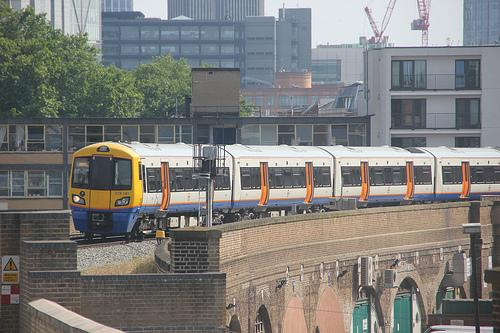In a single sentence, summarize the key components of the image and their locations. The image features a modern train on elevated tracks, surrounded by urban buildings and distant construction cranes. Briefly mention the central theme of the image and the dominant colors seen. The central theme of the image is urban transportation, with dominant colors including blue, white, and grey. Point out any interesting details about the train in the image. The train has a sleek, modern design with a predominantly blue and white color scheme. Describe the scene where the image takes place in terms of the elements captured. The scene takes place in an urban setting with a train on elevated tracks, surrounded by various buildings and distant construction cranes. Describe the overall atmosphere of the image, considering its elements and colors. The image conveys a bustling urban atmosphere, characterized by a modern train system and ongoing construction in the background. Highlight the key elements of the image and their interrelationship. The key elements include the modern train, elevated tracks, and urban buildings, all contributing to the theme of urban transportation and development. Mention any three unique features seen in the image. Three unique features in the image are the modern design of the train, the elevated tracks, and the distant construction cranes. 